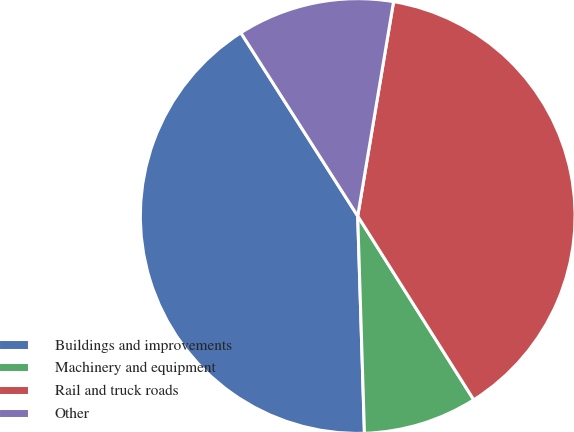<chart> <loc_0><loc_0><loc_500><loc_500><pie_chart><fcel>Buildings and improvements<fcel>Machinery and equipment<fcel>Rail and truck roads<fcel>Other<nl><fcel>41.46%<fcel>8.47%<fcel>38.4%<fcel>11.67%<nl></chart> 